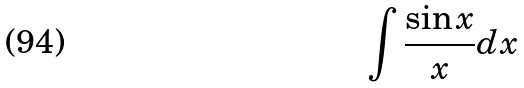Convert formula to latex. <formula><loc_0><loc_0><loc_500><loc_500>\int \frac { \sin x } { x } d x</formula> 